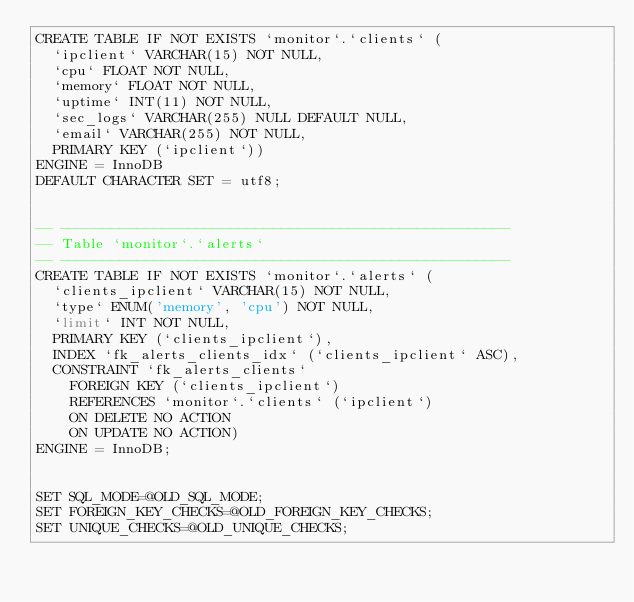<code> <loc_0><loc_0><loc_500><loc_500><_SQL_>CREATE TABLE IF NOT EXISTS `monitor`.`clients` (
  `ipclient` VARCHAR(15) NOT NULL,
  `cpu` FLOAT NOT NULL,
  `memory` FLOAT NOT NULL,
  `uptime` INT(11) NOT NULL,
  `sec_logs` VARCHAR(255) NULL DEFAULT NULL,
  `email` VARCHAR(255) NOT NULL,
  PRIMARY KEY (`ipclient`))
ENGINE = InnoDB
DEFAULT CHARACTER SET = utf8;


-- -----------------------------------------------------
-- Table `monitor`.`alerts`
-- -----------------------------------------------------
CREATE TABLE IF NOT EXISTS `monitor`.`alerts` (
  `clients_ipclient` VARCHAR(15) NOT NULL,
  `type` ENUM('memory', 'cpu') NOT NULL,
  `limit` INT NOT NULL,
  PRIMARY KEY (`clients_ipclient`),
  INDEX `fk_alerts_clients_idx` (`clients_ipclient` ASC),
  CONSTRAINT `fk_alerts_clients`
    FOREIGN KEY (`clients_ipclient`)
    REFERENCES `monitor`.`clients` (`ipclient`)
    ON DELETE NO ACTION
    ON UPDATE NO ACTION)
ENGINE = InnoDB;


SET SQL_MODE=@OLD_SQL_MODE;
SET FOREIGN_KEY_CHECKS=@OLD_FOREIGN_KEY_CHECKS;
SET UNIQUE_CHECKS=@OLD_UNIQUE_CHECKS;
</code> 